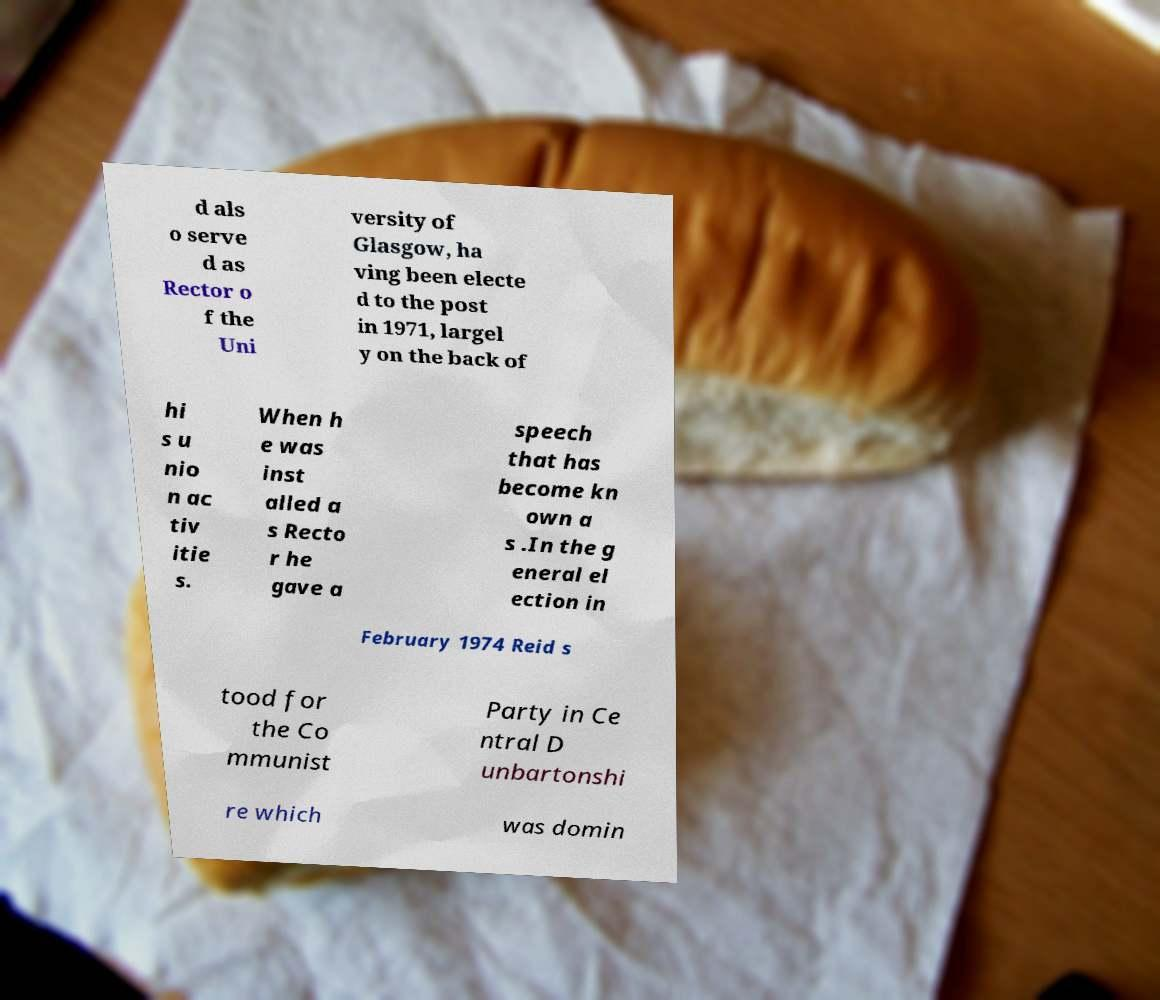Please identify and transcribe the text found in this image. d als o serve d as Rector o f the Uni versity of Glasgow, ha ving been electe d to the post in 1971, largel y on the back of hi s u nio n ac tiv itie s. When h e was inst alled a s Recto r he gave a speech that has become kn own a s .In the g eneral el ection in February 1974 Reid s tood for the Co mmunist Party in Ce ntral D unbartonshi re which was domin 